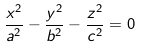<formula> <loc_0><loc_0><loc_500><loc_500>\frac { x ^ { 2 } } { a ^ { 2 } } - \frac { y ^ { 2 } } { b ^ { 2 } } - \frac { z ^ { 2 } } { c ^ { 2 } } = 0</formula> 